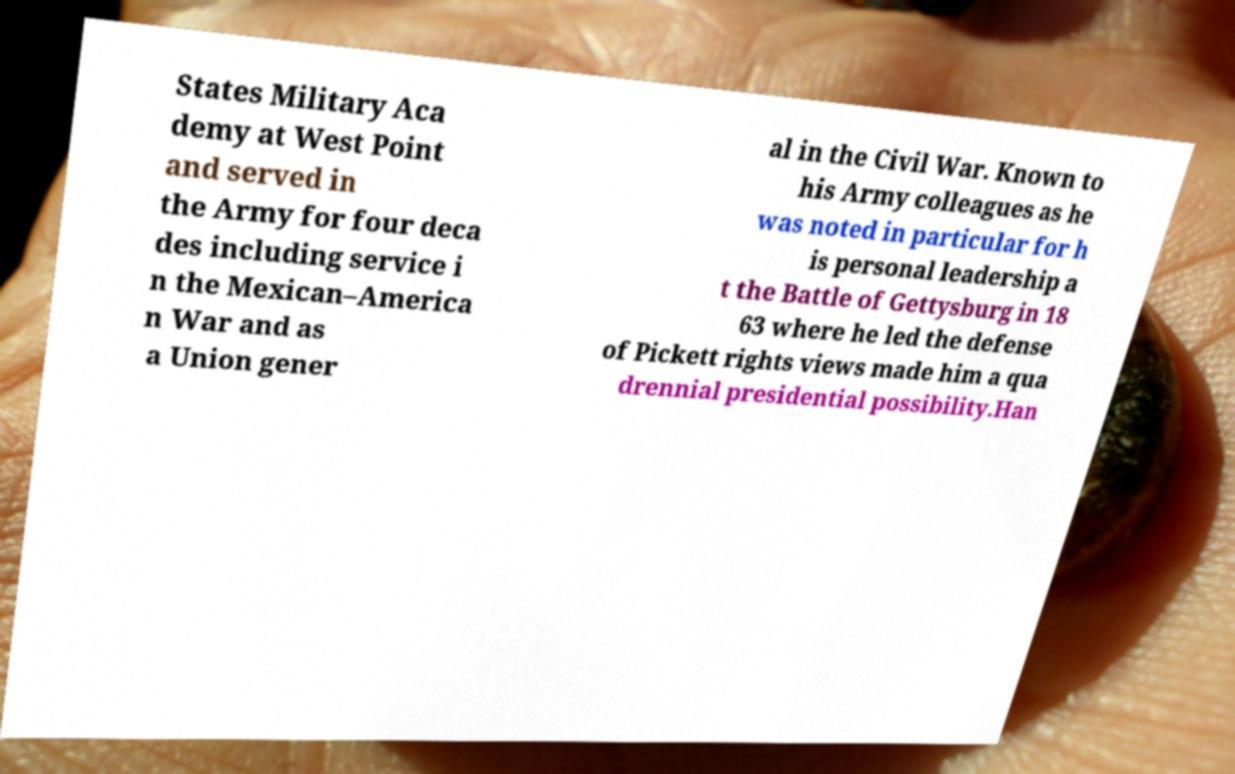I need the written content from this picture converted into text. Can you do that? States Military Aca demy at West Point and served in the Army for four deca des including service i n the Mexican–America n War and as a Union gener al in the Civil War. Known to his Army colleagues as he was noted in particular for h is personal leadership a t the Battle of Gettysburg in 18 63 where he led the defense of Pickett rights views made him a qua drennial presidential possibility.Han 